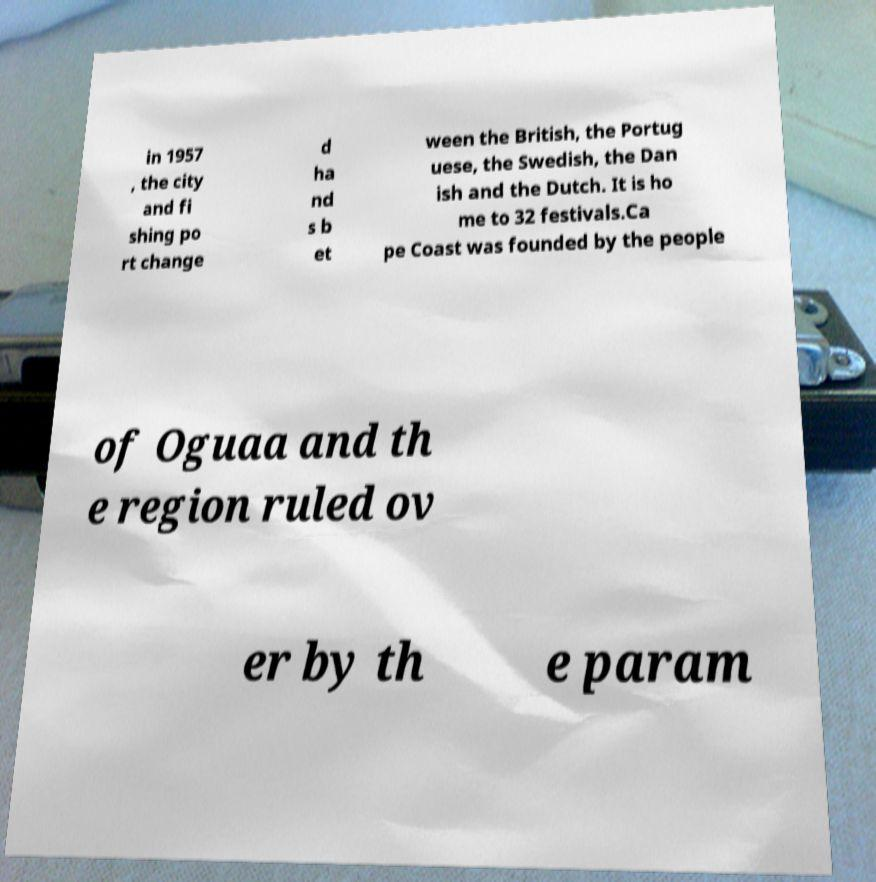I need the written content from this picture converted into text. Can you do that? in 1957 , the city and fi shing po rt change d ha nd s b et ween the British, the Portug uese, the Swedish, the Dan ish and the Dutch. It is ho me to 32 festivals.Ca pe Coast was founded by the people of Oguaa and th e region ruled ov er by th e param 